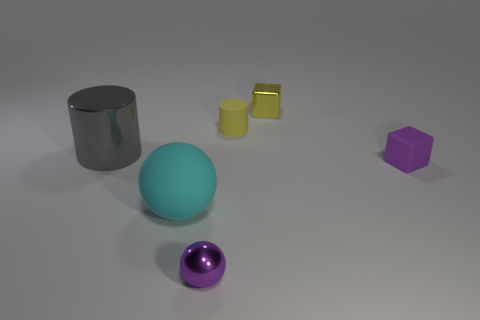The metallic object in front of the large matte thing has what shape?
Offer a very short reply. Sphere. What material is the small cube that is the same color as the small matte cylinder?
Provide a short and direct response. Metal. There is a metal object that is right of the tiny shiny object in front of the gray object; what is its color?
Ensure brevity in your answer.  Yellow. Do the purple sphere and the rubber cylinder have the same size?
Provide a short and direct response. Yes. There is a small purple object that is the same shape as the big cyan thing; what is its material?
Your response must be concise. Metal. What number of spheres have the same size as the yellow metallic object?
Ensure brevity in your answer.  1. What color is the small object that is made of the same material as the tiny purple block?
Give a very brief answer. Yellow. Are there fewer small purple blocks than purple matte spheres?
Make the answer very short. No. What number of yellow things are either small cylinders or rubber objects?
Provide a succinct answer. 1. How many things are on the left side of the purple rubber cube and to the right of the large shiny cylinder?
Keep it short and to the point. 4. 